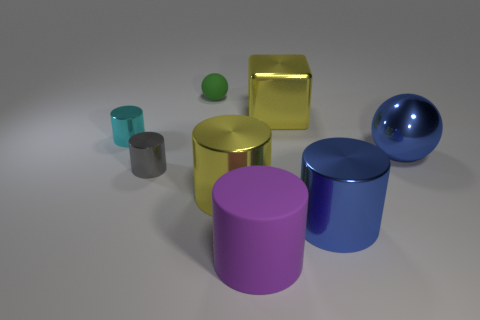Are there any small rubber objects of the same color as the large rubber cylinder?
Provide a succinct answer. No. The blue ball has what size?
Provide a succinct answer. Large. Do the big purple object and the large blue sphere have the same material?
Make the answer very short. No. How many objects are on the right side of the yellow cylinder in front of the yellow metal thing behind the cyan object?
Keep it short and to the point. 4. There is a big object that is in front of the blue cylinder; what is its shape?
Provide a succinct answer. Cylinder. How many other things are there of the same material as the tiny cyan cylinder?
Keep it short and to the point. 5. Does the small ball have the same color as the big metallic cube?
Your response must be concise. No. Are there fewer purple matte things that are in front of the purple matte thing than big shiny objects in front of the large blue shiny ball?
Offer a very short reply. Yes. The large rubber object that is the same shape as the small cyan shiny thing is what color?
Provide a succinct answer. Purple. Does the sphere to the left of the blue cylinder have the same size as the purple rubber cylinder?
Keep it short and to the point. No. 